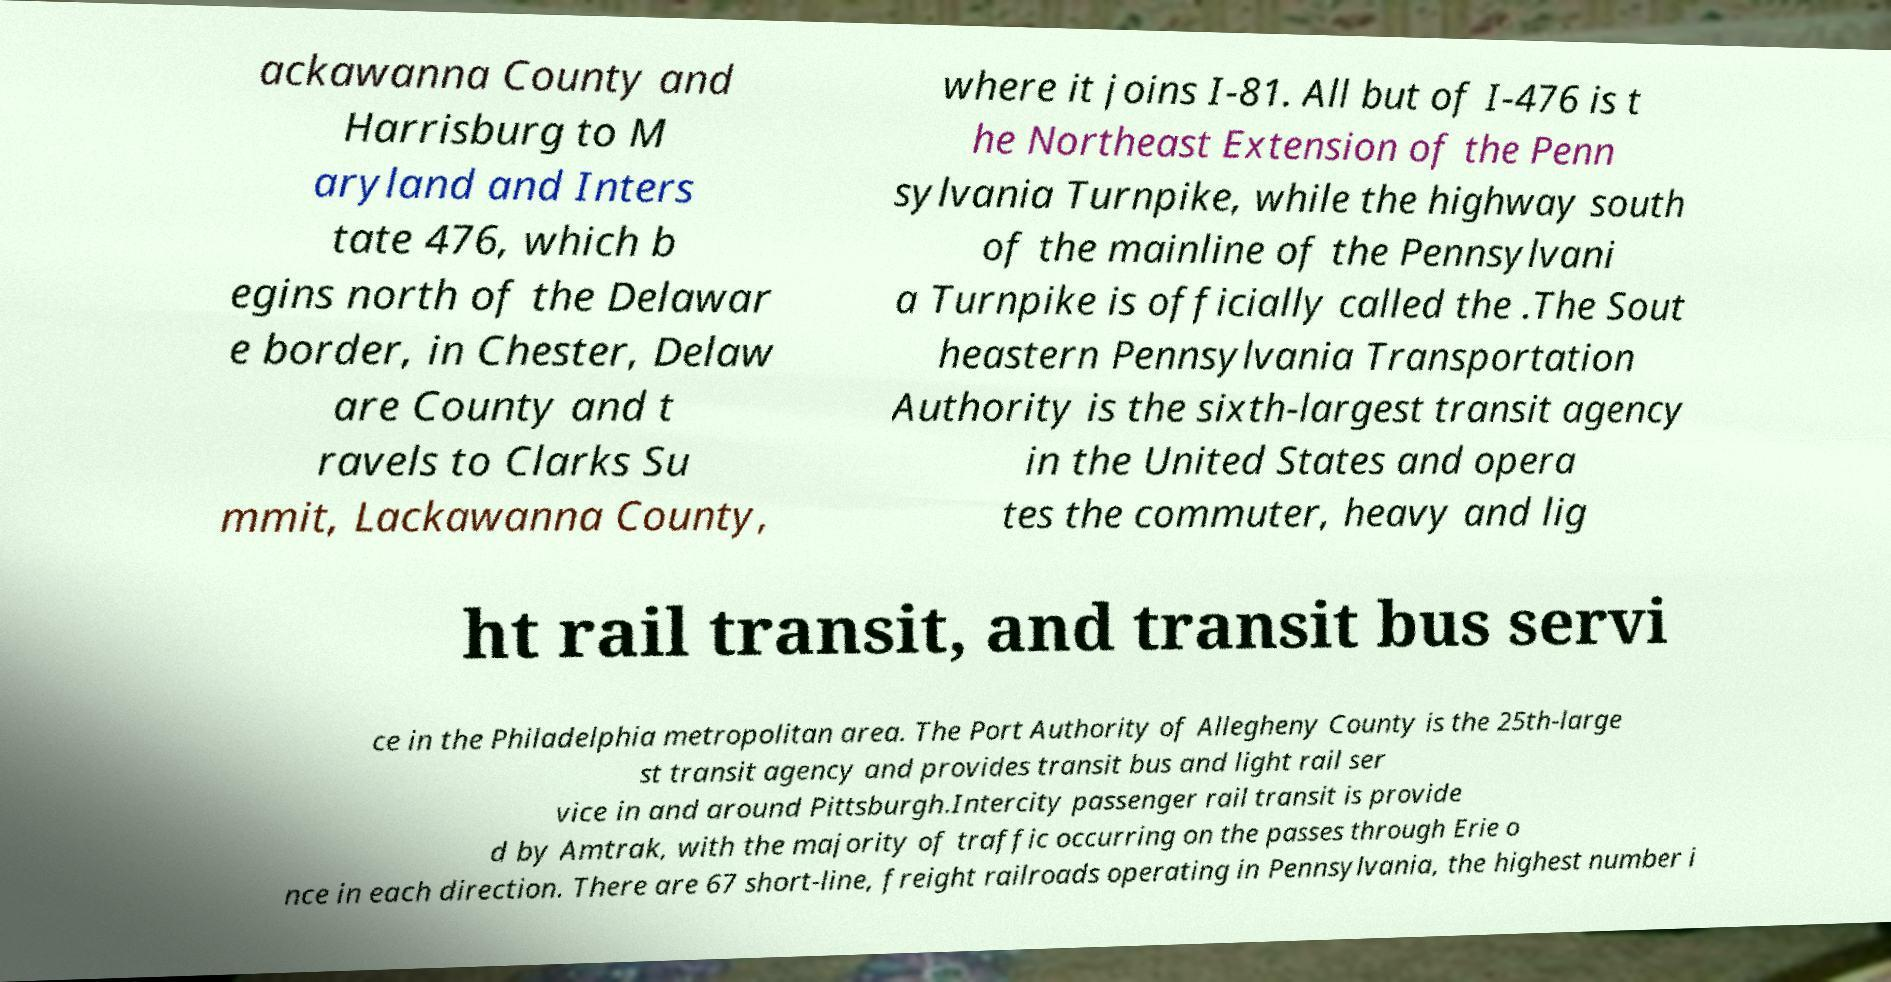For documentation purposes, I need the text within this image transcribed. Could you provide that? ackawanna County and Harrisburg to M aryland and Inters tate 476, which b egins north of the Delawar e border, in Chester, Delaw are County and t ravels to Clarks Su mmit, Lackawanna County, where it joins I-81. All but of I-476 is t he Northeast Extension of the Penn sylvania Turnpike, while the highway south of the mainline of the Pennsylvani a Turnpike is officially called the .The Sout heastern Pennsylvania Transportation Authority is the sixth-largest transit agency in the United States and opera tes the commuter, heavy and lig ht rail transit, and transit bus servi ce in the Philadelphia metropolitan area. The Port Authority of Allegheny County is the 25th-large st transit agency and provides transit bus and light rail ser vice in and around Pittsburgh.Intercity passenger rail transit is provide d by Amtrak, with the majority of traffic occurring on the passes through Erie o nce in each direction. There are 67 short-line, freight railroads operating in Pennsylvania, the highest number i 